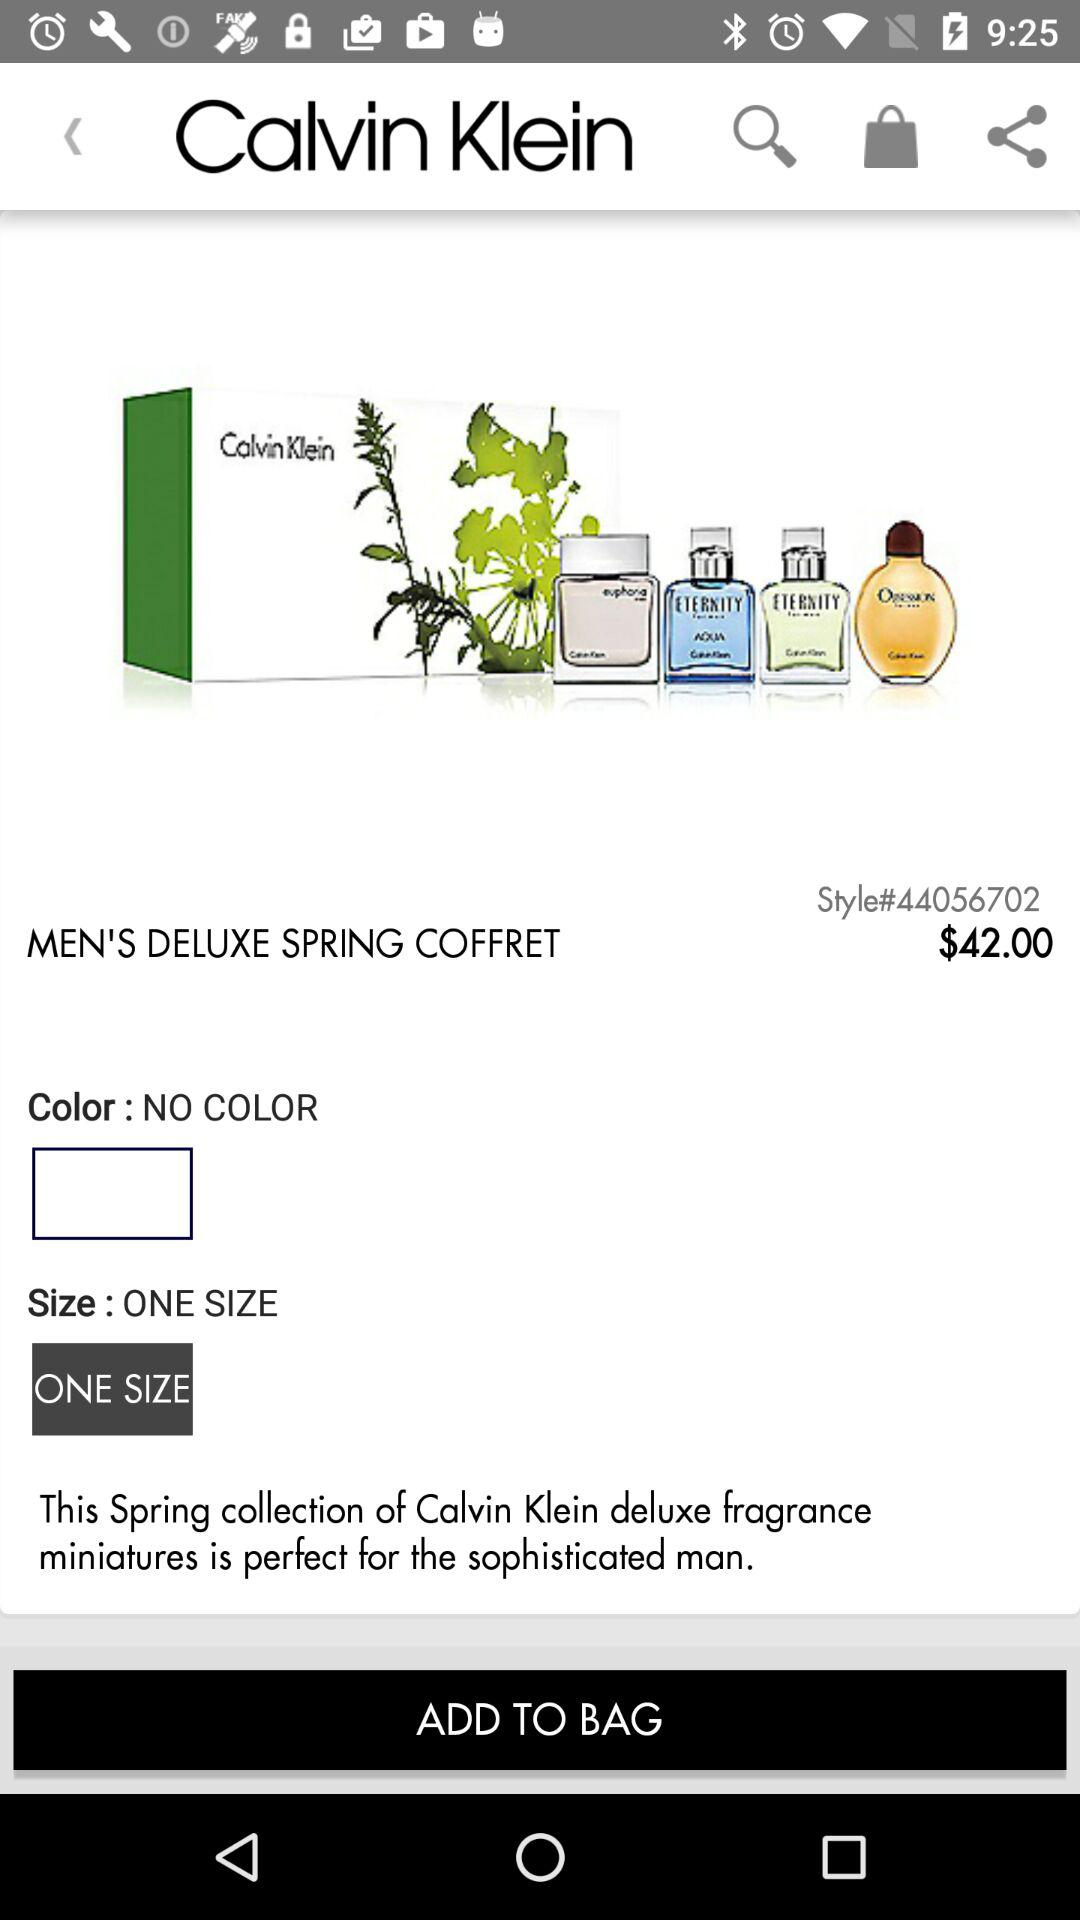How many sizes are available for this item?
Answer the question using a single word or phrase. 1 